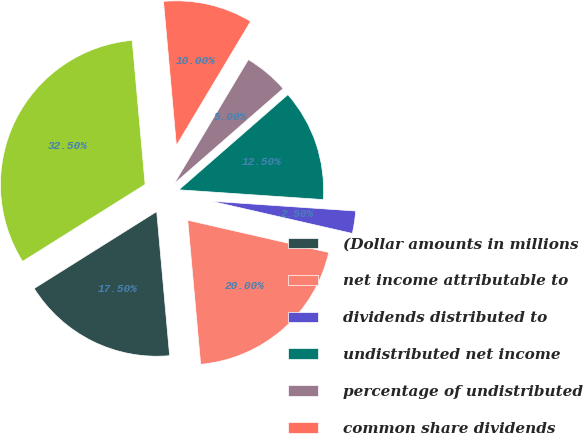<chart> <loc_0><loc_0><loc_500><loc_500><pie_chart><fcel>(Dollar amounts in millions<fcel>net income attributable to<fcel>dividends distributed to<fcel>undistributed net income<fcel>percentage of undistributed<fcel>common share dividends<fcel>Weighted-average shares<nl><fcel>17.5%<fcel>20.0%<fcel>2.5%<fcel>12.5%<fcel>5.0%<fcel>10.0%<fcel>32.5%<nl></chart> 